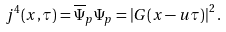Convert formula to latex. <formula><loc_0><loc_0><loc_500><loc_500>j ^ { 4 } ( x , \tau ) = \overline { \Psi } _ { p } \Psi _ { p } = \left | G ( x - u \tau ) \right | ^ { 2 } .</formula> 